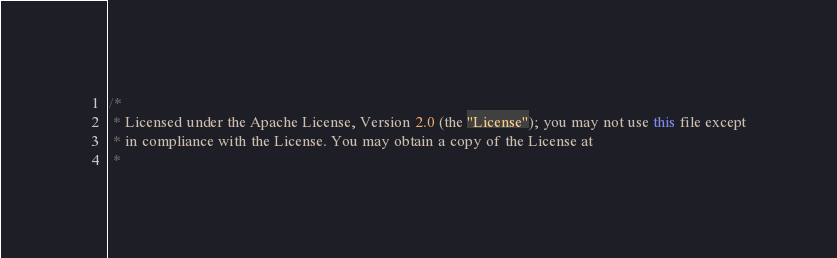<code> <loc_0><loc_0><loc_500><loc_500><_Java_>/*
 * Licensed under the Apache License, Version 2.0 (the "License"); you may not use this file except
 * in compliance with the License. You may obtain a copy of the License at
 *</code> 